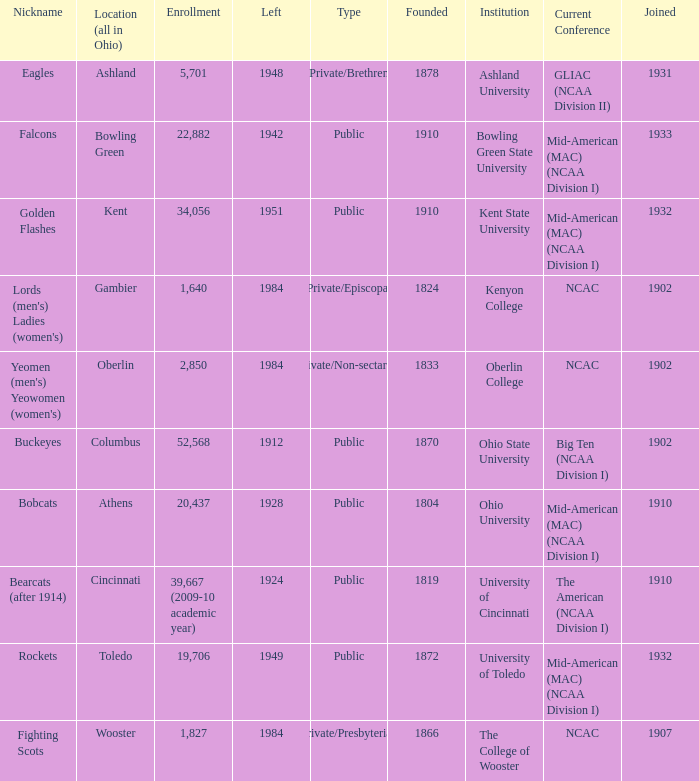What is the enrollment for Ashland University? 5701.0. 